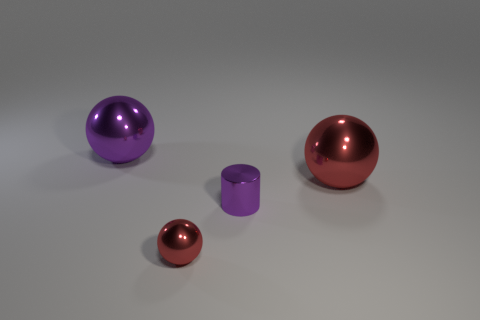What number of things are the same color as the small metal sphere?
Your answer should be very brief. 1. There is a sphere to the right of the cylinder; is its color the same as the sphere in front of the large red thing?
Keep it short and to the point. Yes. Is there anything else of the same color as the tiny metal ball?
Your response must be concise. Yes. What number of objects are small metallic spheres left of the tiny shiny cylinder or large things right of the tiny red object?
Your answer should be very brief. 2. What is the material of the small thing that is the same shape as the large purple shiny object?
Ensure brevity in your answer.  Metal. What number of metal things are either purple things or large gray cubes?
Your response must be concise. 2. There is another red thing that is made of the same material as the tiny red object; what shape is it?
Offer a very short reply. Sphere. How many other small objects are the same shape as the tiny purple object?
Provide a succinct answer. 0. Is the shape of the big object right of the big purple sphere the same as the red object left of the metallic cylinder?
Your response must be concise. Yes. What number of objects are either small brown metal things or big spheres on the left side of the purple shiny cylinder?
Your answer should be very brief. 1. 